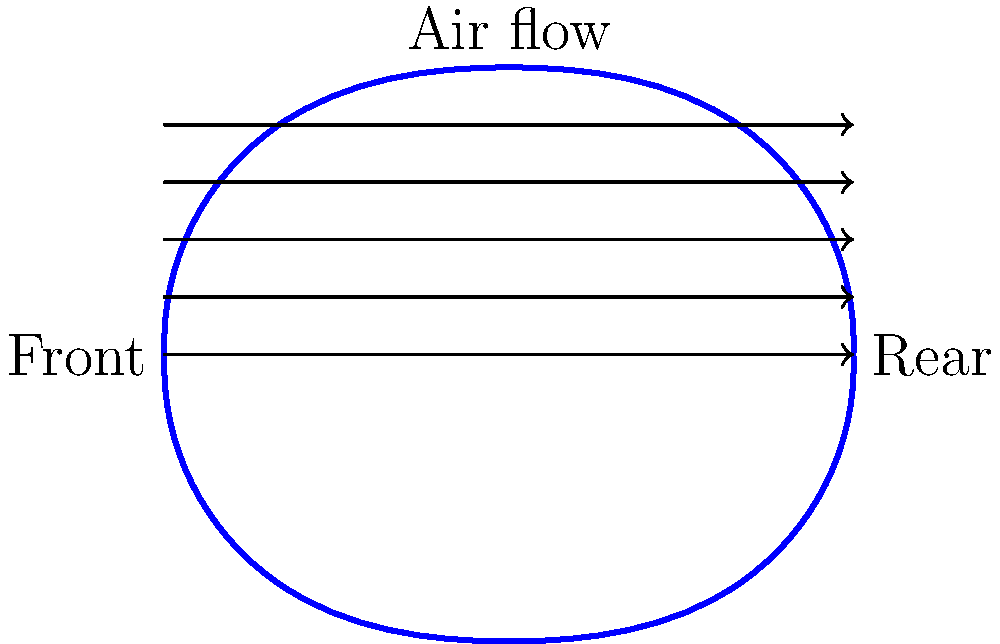In the futuristic racing anime "Neo Tokyo Drift," you're tasked with designing an aerodynamic vehicle for the protagonist. Given the streamlined shape shown in the diagram, which represents a cross-section of the vehicle, what primary aerodynamic principle is being utilized to reduce drag? To answer this question, let's break down the aerodynamic principles at play:

1. The shape of the vehicle is streamlined, with a smooth, curved profile from front to rear.

2. The front of the vehicle (left side) is more pointed, while the rear (right side) has a gradual taper.

3. This shape is designed to minimize air resistance, or drag, as the vehicle moves through the air.

4. The primary aerodynamic principle being utilized here is known as streamlining.

5. Streamlining works by:
   a) Allowing air to flow smoothly over the vehicle's surface
   b) Reducing the formation of turbulent air behind the vehicle
   c) Minimizing the pressure difference between the front and rear of the vehicle

6. This shape is inspired by natural streamlined forms, such as the bodies of fish or birds, which have evolved to move efficiently through fluids (water or air).

7. In the context of a futuristic racing anime, this streamlined design would allow the vehicle to achieve higher speeds with less power, improving its racing performance.

The primary aerodynamic principle being utilized in this design is streamlining, which reduces drag by optimizing the vehicle's shape to minimize air resistance.
Answer: Streamlining 